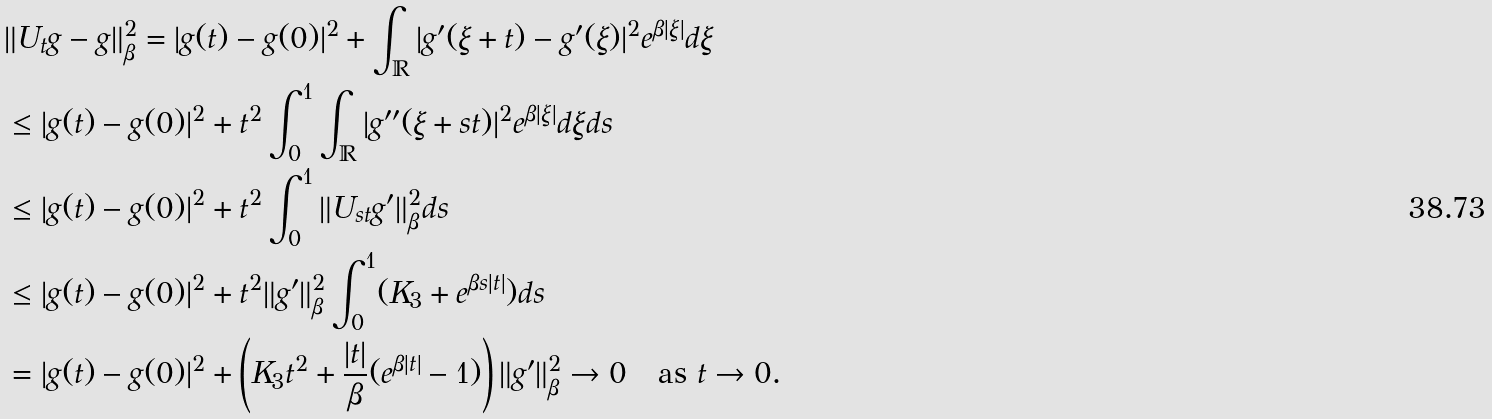<formula> <loc_0><loc_0><loc_500><loc_500>& \| U _ { t } g - g \| _ { \beta } ^ { 2 } = | g ( t ) - g ( 0 ) | ^ { 2 } + \int _ { \mathbb { R } } | g ^ { \prime } ( \xi + t ) - g ^ { \prime } ( \xi ) | ^ { 2 } e ^ { \beta | \xi | } d \xi \\ & \leq | g ( t ) - g ( 0 ) | ^ { 2 } + t ^ { 2 } \int _ { 0 } ^ { 1 } \int _ { \mathbb { R } } | g ^ { \prime \prime } ( \xi + s t ) | ^ { 2 } e ^ { \beta | \xi | } d \xi d s \\ & \leq | g ( t ) - g ( 0 ) | ^ { 2 } + t ^ { 2 } \int _ { 0 } ^ { 1 } \| U _ { s t } g ^ { \prime } \| _ { \beta } ^ { 2 } d s \\ & \leq | g ( t ) - g ( 0 ) | ^ { 2 } + t ^ { 2 } \| g ^ { \prime } \| _ { \beta } ^ { 2 } \int _ { 0 } ^ { 1 } ( K _ { 3 } + e ^ { \beta s | t | } ) d s \\ & = | g ( t ) - g ( 0 ) | ^ { 2 } + \left ( K _ { 3 } t ^ { 2 } + \frac { | t | } { \beta } ( e ^ { \beta | t | } - 1 ) \right ) \| g ^ { \prime } \| _ { \beta } ^ { 2 } \rightarrow 0 \quad \text {as $t \rightarrow 0$.}</formula> 